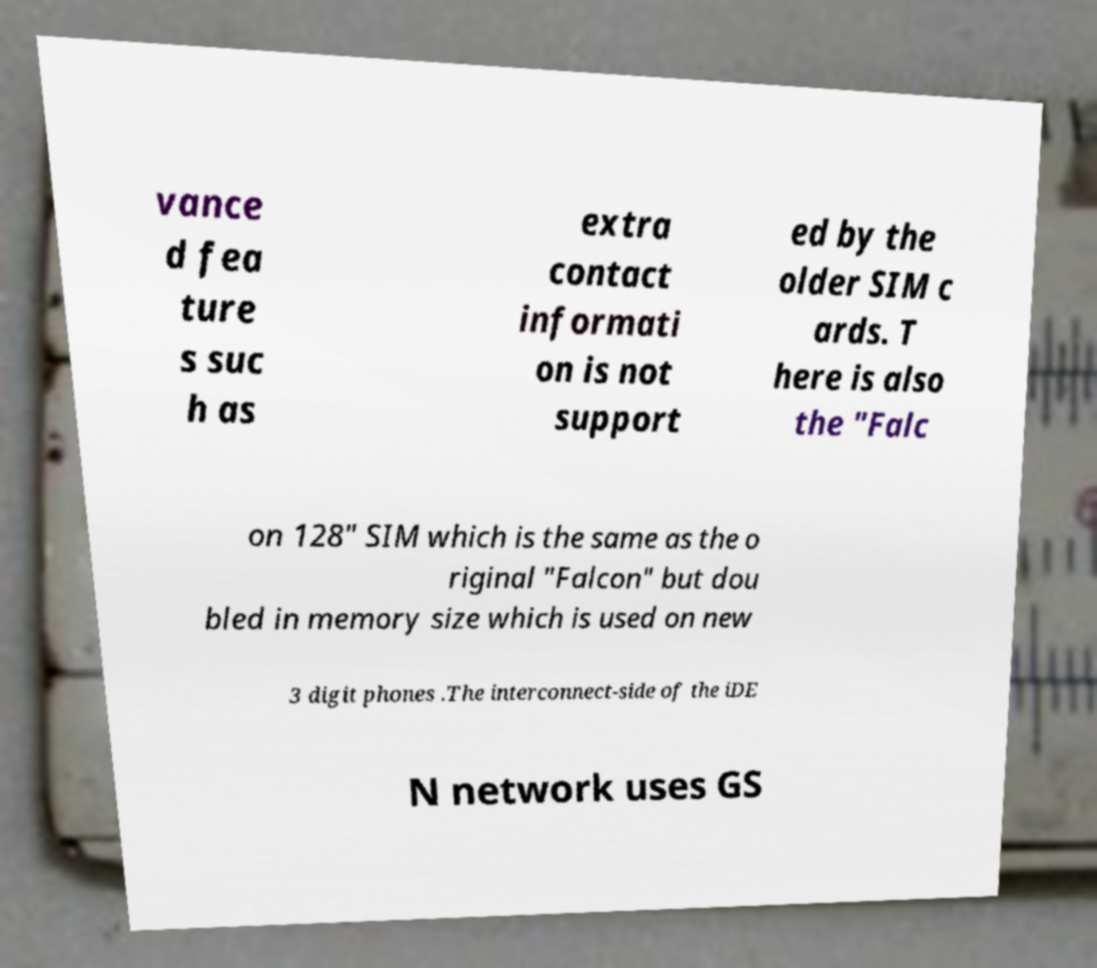For documentation purposes, I need the text within this image transcribed. Could you provide that? vance d fea ture s suc h as extra contact informati on is not support ed by the older SIM c ards. T here is also the "Falc on 128" SIM which is the same as the o riginal "Falcon" but dou bled in memory size which is used on new 3 digit phones .The interconnect-side of the iDE N network uses GS 